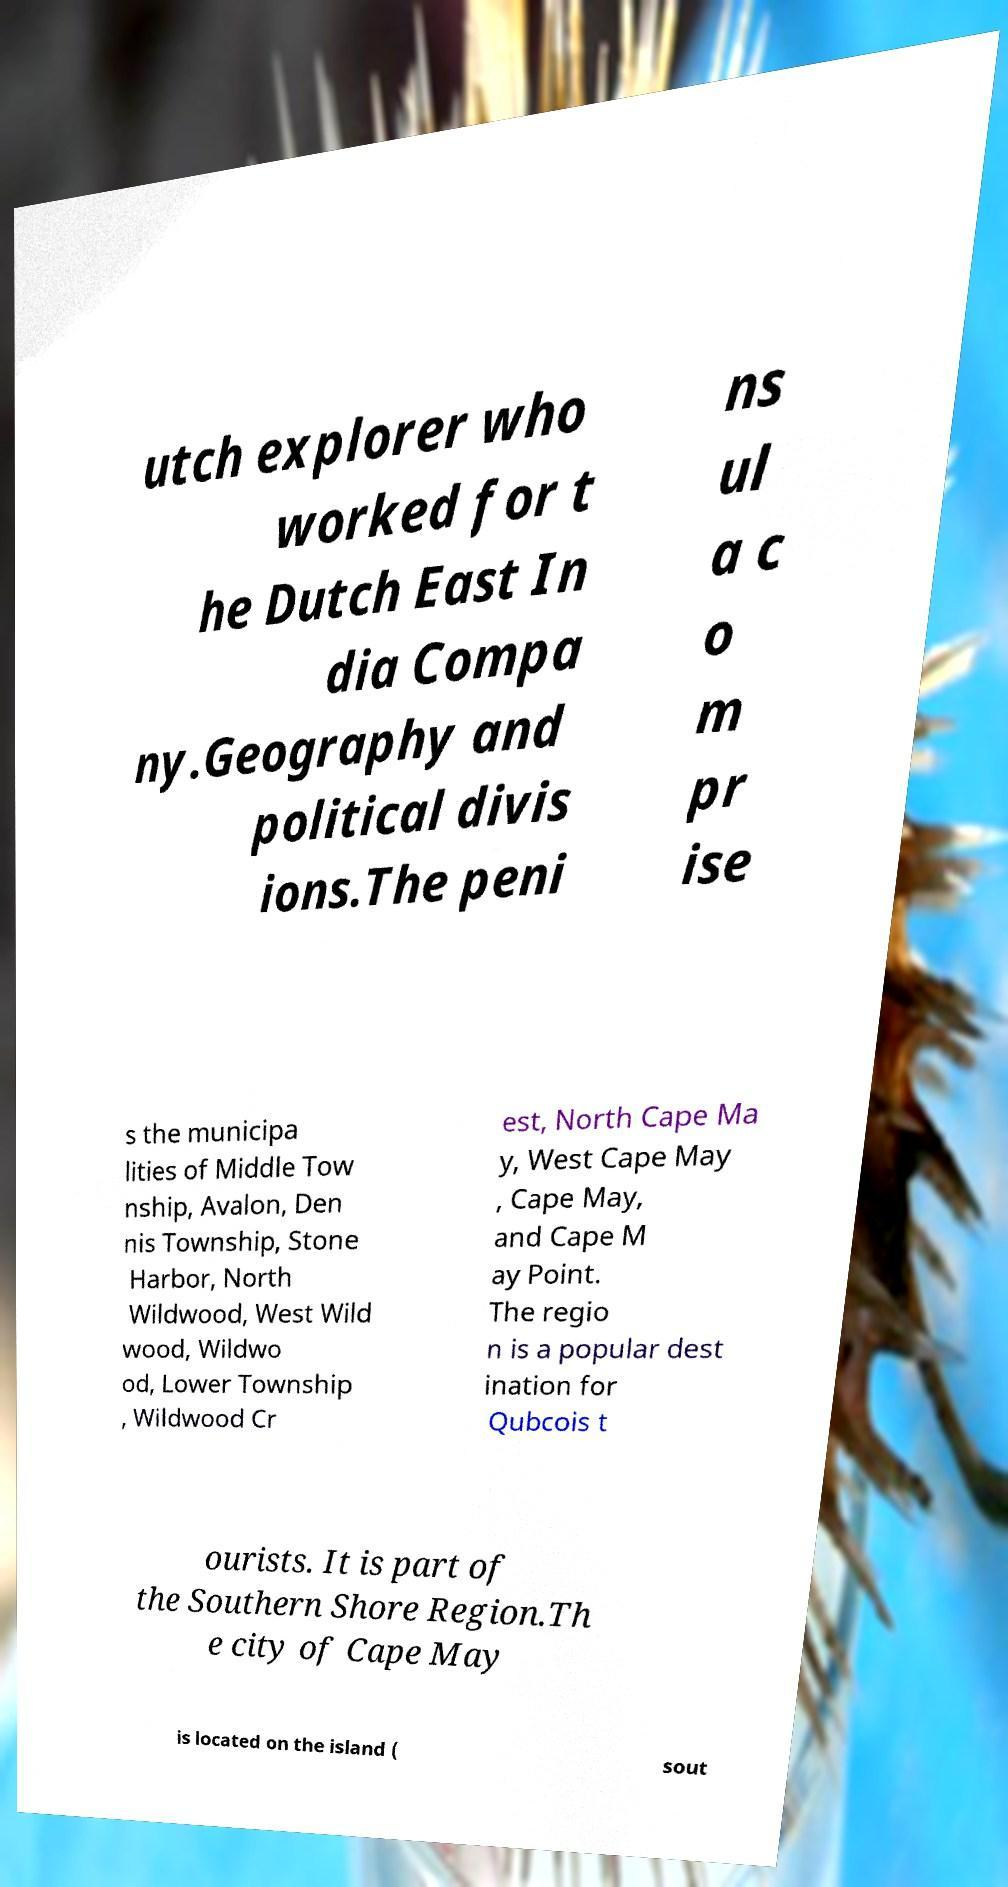For documentation purposes, I need the text within this image transcribed. Could you provide that? utch explorer who worked for t he Dutch East In dia Compa ny.Geography and political divis ions.The peni ns ul a c o m pr ise s the municipa lities of Middle Tow nship, Avalon, Den nis Township, Stone Harbor, North Wildwood, West Wild wood, Wildwo od, Lower Township , Wildwood Cr est, North Cape Ma y, West Cape May , Cape May, and Cape M ay Point. The regio n is a popular dest ination for Qubcois t ourists. It is part of the Southern Shore Region.Th e city of Cape May is located on the island ( sout 